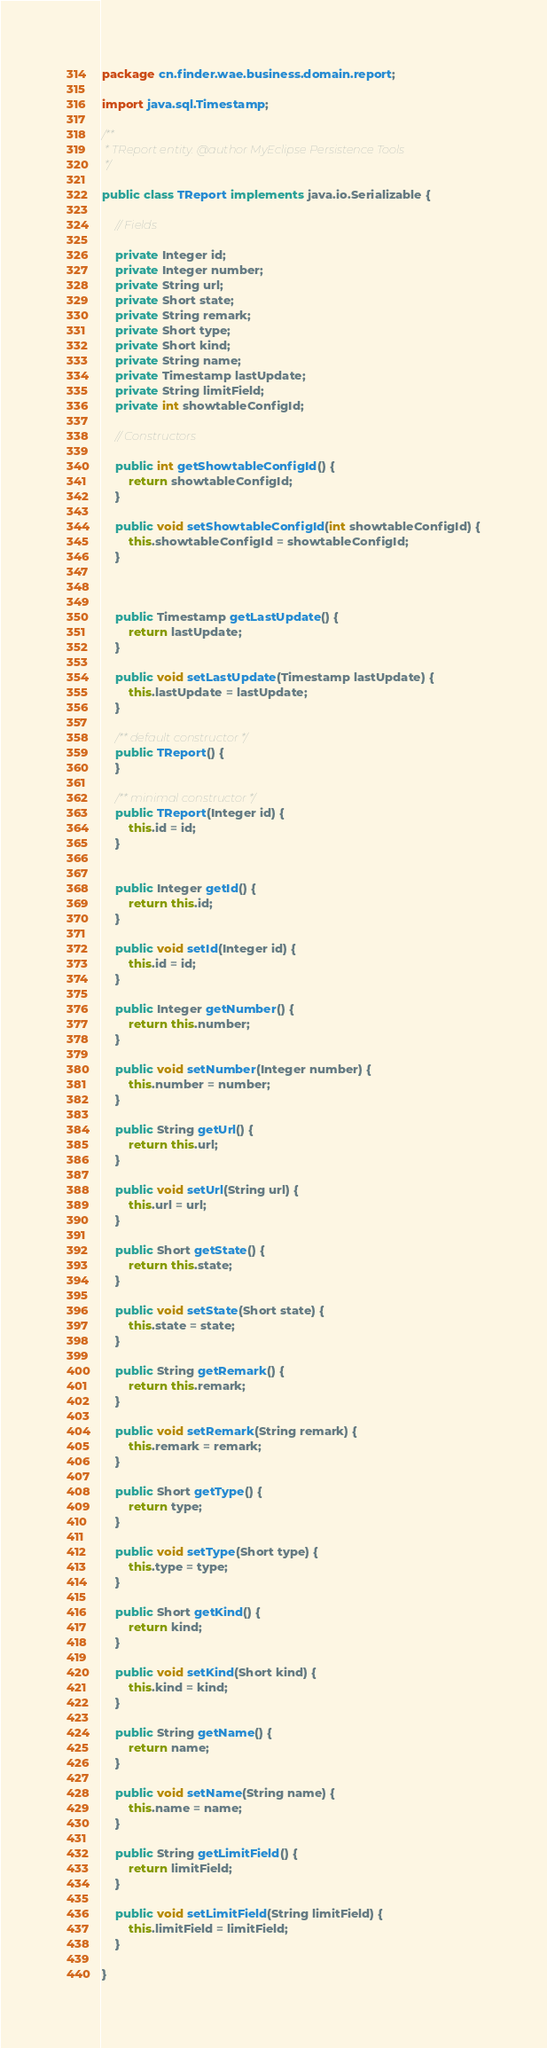<code> <loc_0><loc_0><loc_500><loc_500><_Java_>package cn.finder.wae.business.domain.report;

import java.sql.Timestamp;

/**
 * TReport entity. @author MyEclipse Persistence Tools
 */

public class TReport implements java.io.Serializable {

	// Fields

	private Integer id;
	private Integer number;
	private String url;
	private Short state;
	private String remark;
	private Short type;
	private Short kind;
	private String name;
	private Timestamp lastUpdate;
	private String limitField;
	private int showtableConfigId;

	// Constructors

	public int getShowtableConfigId() {
		return showtableConfigId;
	}

	public void setShowtableConfigId(int showtableConfigId) {
		this.showtableConfigId = showtableConfigId;
	}



	public Timestamp getLastUpdate() {
		return lastUpdate;
	}

	public void setLastUpdate(Timestamp lastUpdate) {
		this.lastUpdate = lastUpdate;
	}

	/** default constructor */
	public TReport() {
	}

	/** minimal constructor */
	public TReport(Integer id) {
		this.id = id;
	}


	public Integer getId() {
		return this.id;
	}

	public void setId(Integer id) {
		this.id = id;
	}

	public Integer getNumber() {
		return this.number;
	}

	public void setNumber(Integer number) {
		this.number = number;
	}

	public String getUrl() {
		return this.url;
	}

	public void setUrl(String url) {
		this.url = url;
	}

	public Short getState() {
		return this.state;
	}

	public void setState(Short state) {
		this.state = state;
	}

	public String getRemark() {
		return this.remark;
	}

	public void setRemark(String remark) {
		this.remark = remark;
	}

	public Short getType() {
		return type;
	}

	public void setType(Short type) {
		this.type = type;
	}

	public Short getKind() {
		return kind;
	}

	public void setKind(Short kind) {
		this.kind = kind;
	}

	public String getName() {
		return name;
	}

	public void setName(String name) {
		this.name = name;
	}

	public String getLimitField() {
		return limitField;
	}

	public void setLimitField(String limitField) {
		this.limitField = limitField;
	}

}</code> 